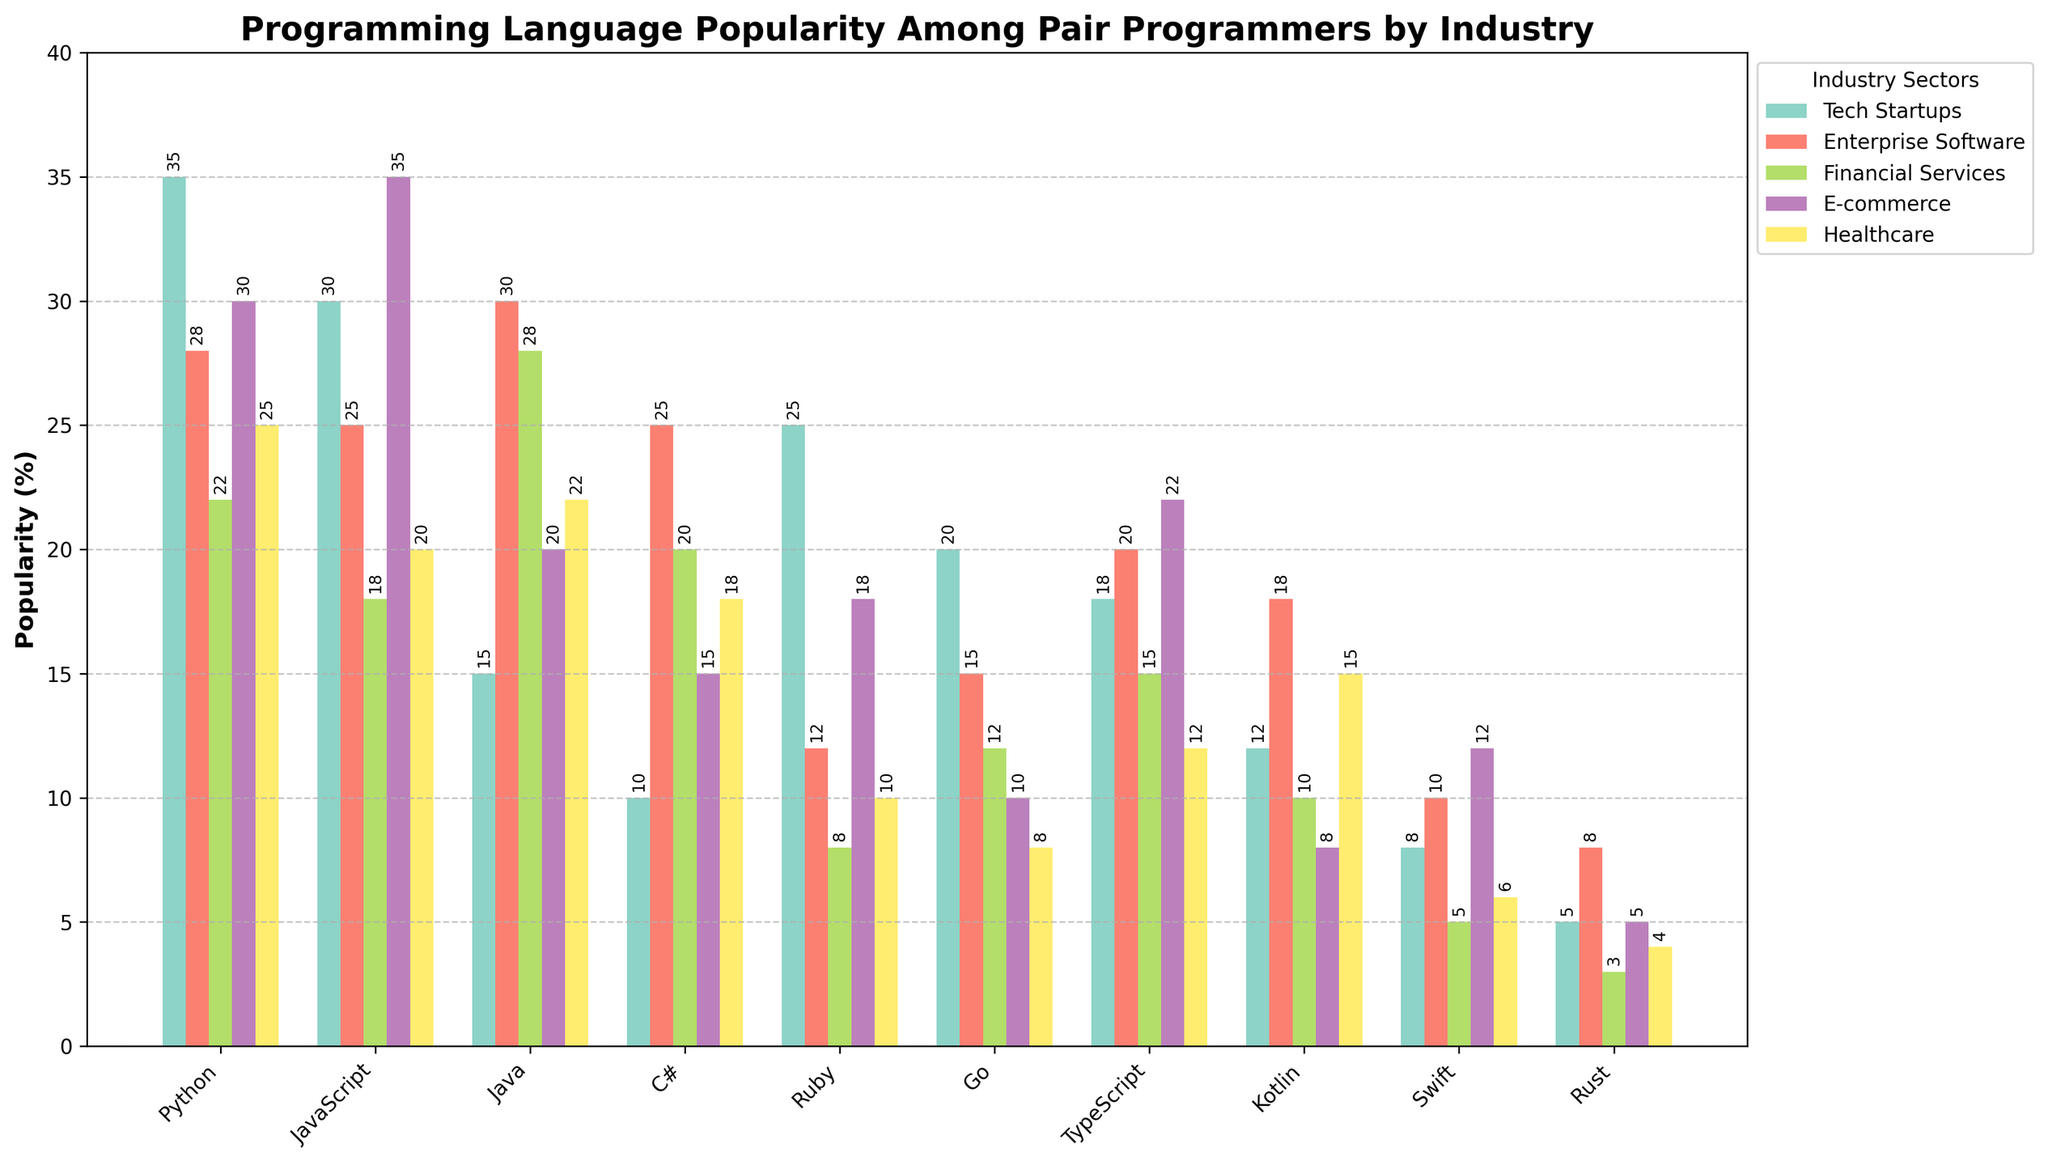What is the most popular programming language in Tech Startups? The tallest bar in the "Tech Startups" section represents the most popular language. Python has the tallest bar in this section.
Answer: Python Which industry sector prefers Ruby the most? The "Ruby" bar's height is highest in the "Tech Startups" section compared to other industry sectors.
Answer: Tech Startups Which programming languages have a similar popularity in Financial Services? By comparing the heights of the bars in the "Financial Services" section, Java and C# have bars of similar height (both around 20%).
Answer: Java and C# How much more popular is JavaScript compared to Kotlin in E-commerce? The height of the JavaScript bar in "E-commerce" is about 35%, and Kotlin's bar is about 8%. The difference is 35% - 8% = 27%.
Answer: 27% Which programming language is the least popular among all industry sectors? The shortest bar across all sections represents the least popular language. Rust has the shortest bar across all sectors.
Answer: Rust What is the combined popularity of Python in Tech Startups and E-commerce? The Python bar is about 35% in Tech Startups and 30% in E-commerce. Adding these gives 35% + 30% = 65%.
Answer: 65% In which industry sector is TypeScript most popular? The height of the TypeScript bar is highest in the "E-commerce" section compared to others.
Answer: E-commerce By how many percentage points is Java more popular in Enterprise Software than in E-commerce? The Java bar is 30% in Enterprise Software and 20% in E-commerce. The difference is 30% - 20% = 10%.
Answer: 10% What is the average popularity of Swift across all industry sectors? Summing the Swift percentages across all sectors: 8 + 10 + 5 + 12 + 6 = 41, there are 5 sectors, so average is 41/5 = 8.2%.
Answer: 8.2% Which programming language has the highest variation in popularity across industry sectors? By visually inspecting the height differences across sectors for each language, Ruby shows the most variation with percentages from 8% to 25%.
Answer: Ruby 